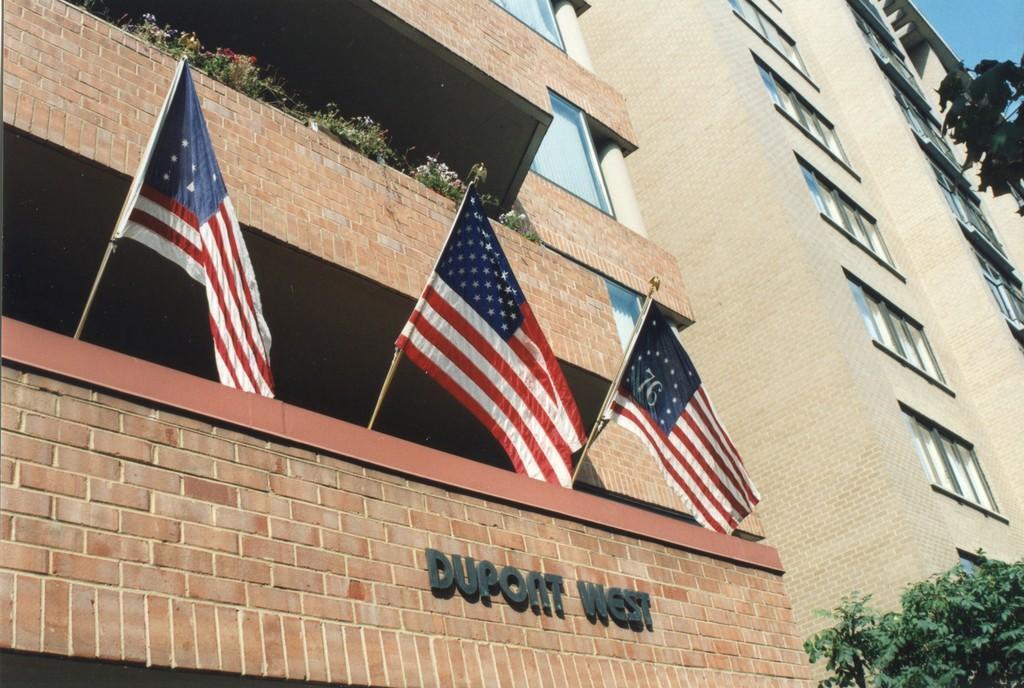Can you describe this image briefly? In the picture I can see flags, buildings, trees, plants and a name on a building. On the right side I can see the sky. 